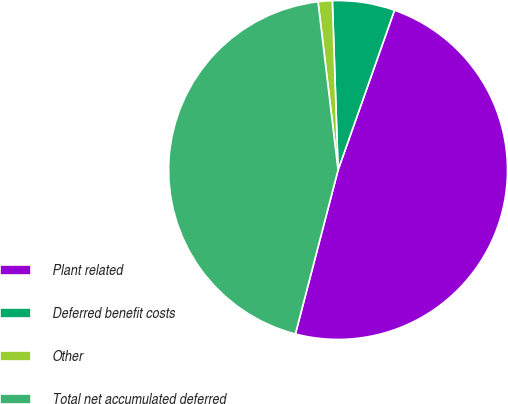Convert chart to OTSL. <chart><loc_0><loc_0><loc_500><loc_500><pie_chart><fcel>Plant related<fcel>Deferred benefit costs<fcel>Other<fcel>Total net accumulated deferred<nl><fcel>48.65%<fcel>5.94%<fcel>1.35%<fcel>44.06%<nl></chart> 